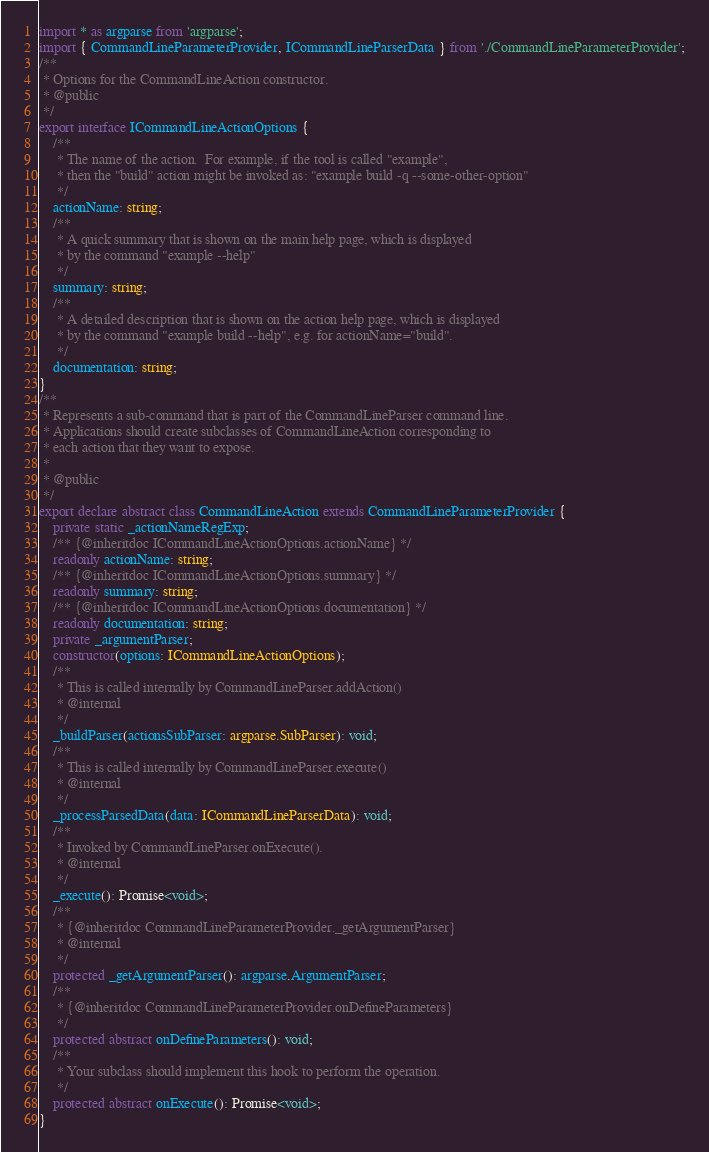<code> <loc_0><loc_0><loc_500><loc_500><_TypeScript_>import * as argparse from 'argparse';
import { CommandLineParameterProvider, ICommandLineParserData } from './CommandLineParameterProvider';
/**
 * Options for the CommandLineAction constructor.
 * @public
 */
export interface ICommandLineActionOptions {
    /**
     * The name of the action.  For example, if the tool is called "example",
     * then the "build" action might be invoked as: "example build -q --some-other-option"
     */
    actionName: string;
    /**
     * A quick summary that is shown on the main help page, which is displayed
     * by the command "example --help"
     */
    summary: string;
    /**
     * A detailed description that is shown on the action help page, which is displayed
     * by the command "example build --help", e.g. for actionName="build".
     */
    documentation: string;
}
/**
 * Represents a sub-command that is part of the CommandLineParser command line.
 * Applications should create subclasses of CommandLineAction corresponding to
 * each action that they want to expose.
 *
 * @public
 */
export declare abstract class CommandLineAction extends CommandLineParameterProvider {
    private static _actionNameRegExp;
    /** {@inheritdoc ICommandLineActionOptions.actionName} */
    readonly actionName: string;
    /** {@inheritdoc ICommandLineActionOptions.summary} */
    readonly summary: string;
    /** {@inheritdoc ICommandLineActionOptions.documentation} */
    readonly documentation: string;
    private _argumentParser;
    constructor(options: ICommandLineActionOptions);
    /**
     * This is called internally by CommandLineParser.addAction()
     * @internal
     */
    _buildParser(actionsSubParser: argparse.SubParser): void;
    /**
     * This is called internally by CommandLineParser.execute()
     * @internal
     */
    _processParsedData(data: ICommandLineParserData): void;
    /**
     * Invoked by CommandLineParser.onExecute().
     * @internal
     */
    _execute(): Promise<void>;
    /**
     * {@inheritdoc CommandLineParameterProvider._getArgumentParser}
     * @internal
     */
    protected _getArgumentParser(): argparse.ArgumentParser;
    /**
     * {@inheritdoc CommandLineParameterProvider.onDefineParameters}
     */
    protected abstract onDefineParameters(): void;
    /**
     * Your subclass should implement this hook to perform the operation.
     */
    protected abstract onExecute(): Promise<void>;
}
</code> 